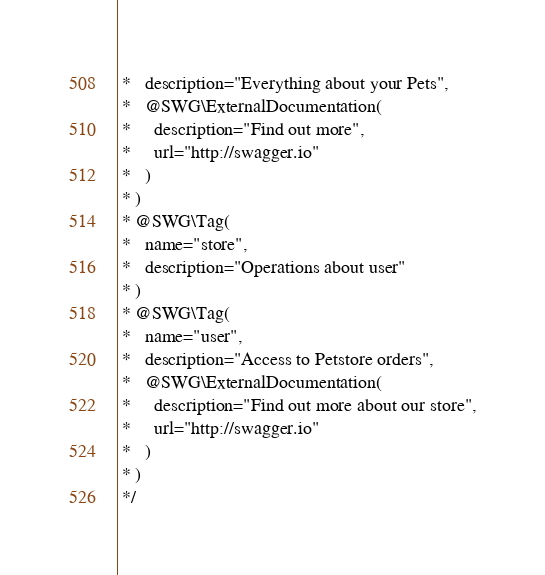<code> <loc_0><loc_0><loc_500><loc_500><_PHP_> *   description="Everything about your Pets",
 *   @SWG\ExternalDocumentation(
 *     description="Find out more",
 *     url="http://swagger.io"
 *   )
 * )
 * @SWG\Tag(
 *   name="store",
 *   description="Operations about user"
 * )
 * @SWG\Tag(
 *   name="user",
 *   description="Access to Petstore orders",
 *   @SWG\ExternalDocumentation(
 *     description="Find out more about our store",
 *     url="http://swagger.io"
 *   )
 * )
 */
</code> 